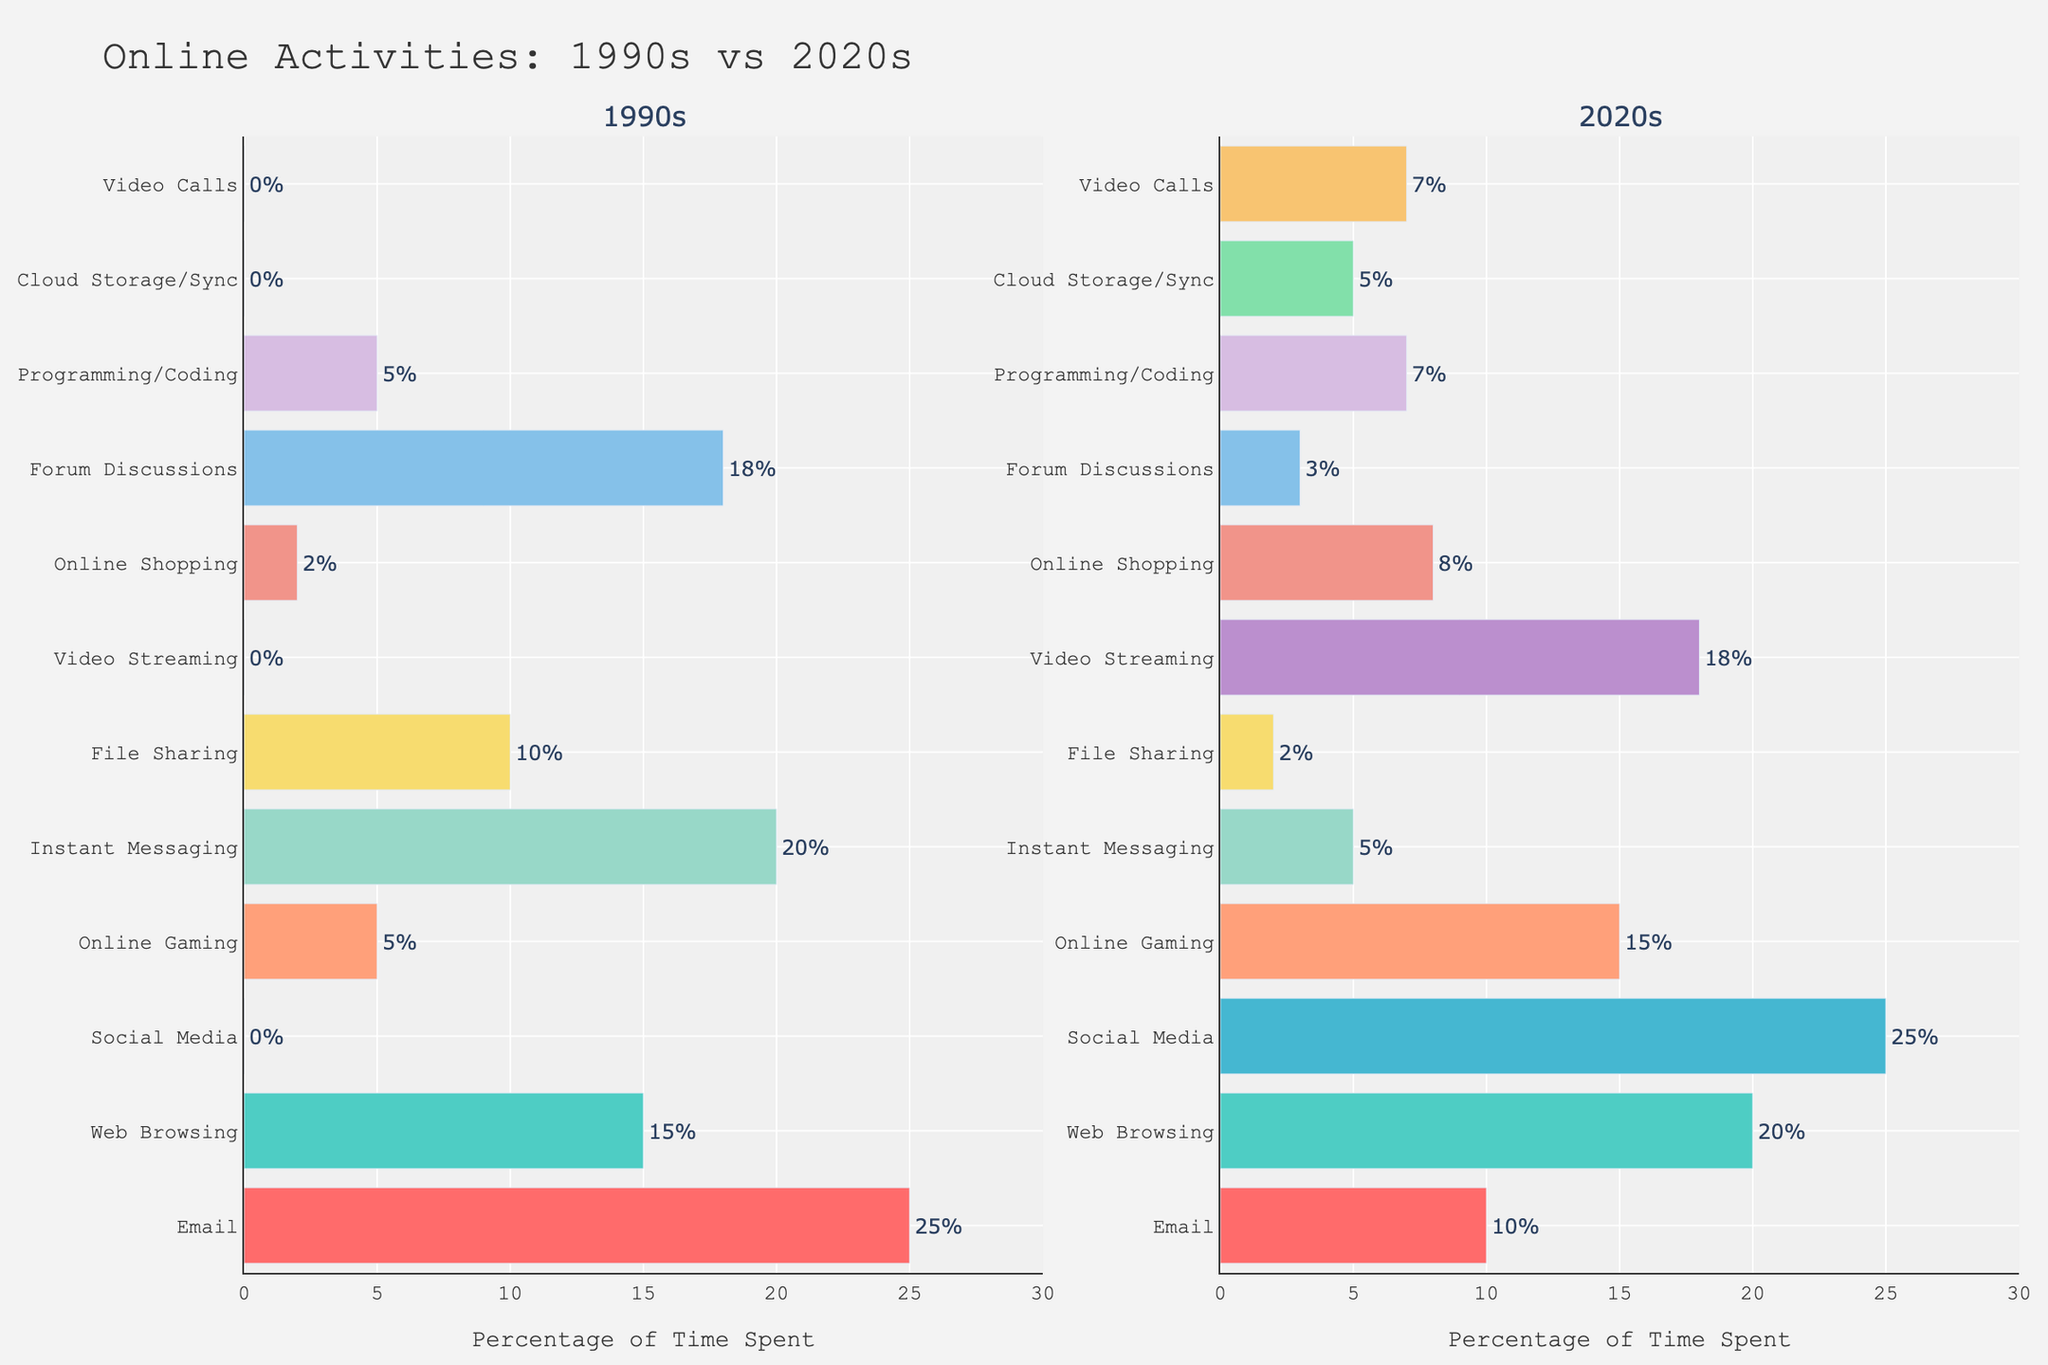What activity in the 2020s has the highest percentage of time spent? From the bar representing the 2020s, observe the height of each bar. The Social Media bar reaches the highest point, indicating 25%.
Answer: Social Media Which activity changed the most in terms of percentage from the 1990s to the 2020s? Calculate the difference in percentages for each activity between the 1990s and the 2020s. The largest difference occurs for Social Media, increasing by 25%.
Answer: Social Media What is the sum of the percentages for Video Streaming and Online Shopping in the 2020s? Identify the percentages for Video Streaming (18%) and Online Shopping (8%) in the 2020s, then add them together: 18 + 8.
Answer: 26% In the 1990s, which activity had the second-highest percentage of time spent? Refer to the bars representing the 1990s and order them by height. The second-highest bar is for Email, at 25%. The highest is Email (25%), followed by Instant Messaging (20%).
Answer: Instant Messaging Which activity in the 2020s increased the most compared to the 1990s? Calculate the increase for each shared activity between the two decades. Social Media increased from 0% to 25%, a 25% increase.
Answer: Social Media Compare the time spent on Web Browsing in the 1990s and 2020s. Which decade had a higher percentage? The bar for Web Browsing in the 2020s (20%) is higher than in the 1990s (15%).
Answer: 2020s What is the combined percentage of time spent on Instant Messaging and Email in the 2020s? Identify the percentages for Instant Messaging (5%) and Email (10%) in the 2020s, then add them together: 10 + 5.
Answer: 15% Which activities were not present in the 1990s but appeared in the 2020s? Observe the bars in the 1990s that show 0% and have non-zero values in the 2020s. These include Social Media, Video Streaming, Cloud Storage/Sync, and Video Calls.
Answer: Social Media, Video Streaming, Cloud Storage/Sync, Video Calls Are there any activities that showed a reduction in time spent from the 1990s to the 2020s? If so, which ones? Compare the percentages of each activity between the two decades. Activities with a reduced percentage include Email, Instant Messaging, File Sharing, and Forum Discussions.
Answer: Email, Instant Messaging, File Sharing, Forum Discussions What is the difference in the percentage of time spent on Programming/Coding between the 1990s and 2020s? Observe the percentages for Programming/Coding in both decades (5% for the 1990s and 7% for the 2020s). Calculate the difference: 7 - 5.
Answer: 2% 